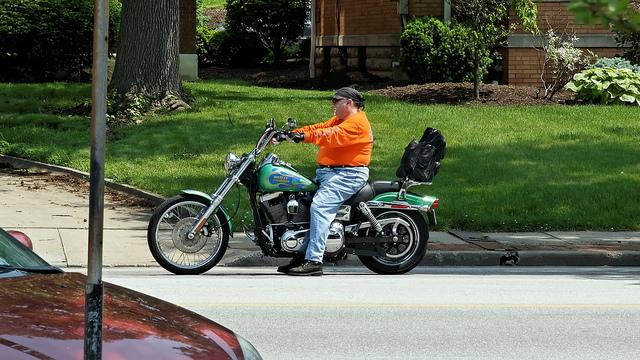What is on the back of the motorcycle?

Choices:
A) suitcase
B) animal
C) backpack
D) person backpack 